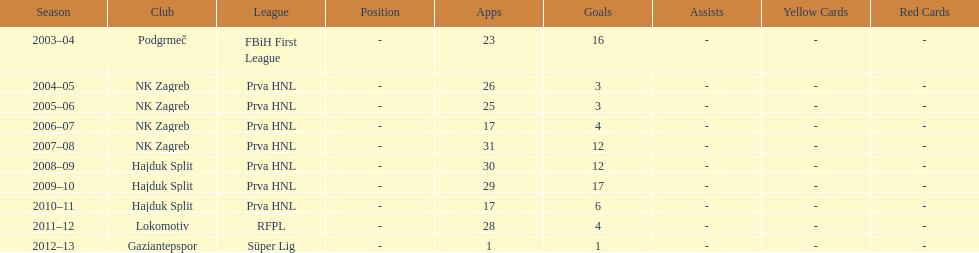At most 26 apps, how many goals were scored in 2004-2005 3. 